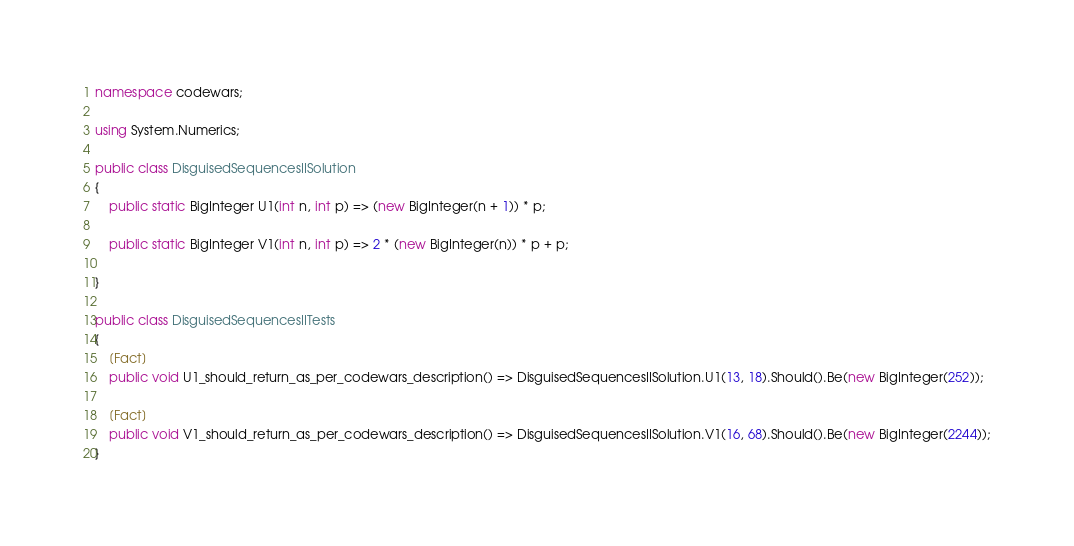Convert code to text. <code><loc_0><loc_0><loc_500><loc_500><_C#_>namespace codewars;

using System.Numerics;

public class DisguisedSequencesIISolution
{
    public static BigInteger U1(int n, int p) => (new BigInteger(n + 1)) * p;

    public static BigInteger V1(int n, int p) => 2 * (new BigInteger(n)) * p + p;

}

public class DisguisedSequencesIITests
{
    [Fact]
    public void U1_should_return_as_per_codewars_description() => DisguisedSequencesIISolution.U1(13, 18).Should().Be(new BigInteger(252));

    [Fact]
    public void V1_should_return_as_per_codewars_description() => DisguisedSequencesIISolution.V1(16, 68).Should().Be(new BigInteger(2244));
}</code> 